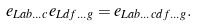Convert formula to latex. <formula><loc_0><loc_0><loc_500><loc_500>e _ { L a b \dots c } e _ { L d f \dots g } = e _ { L a b \dots c d f \dots g } .</formula> 